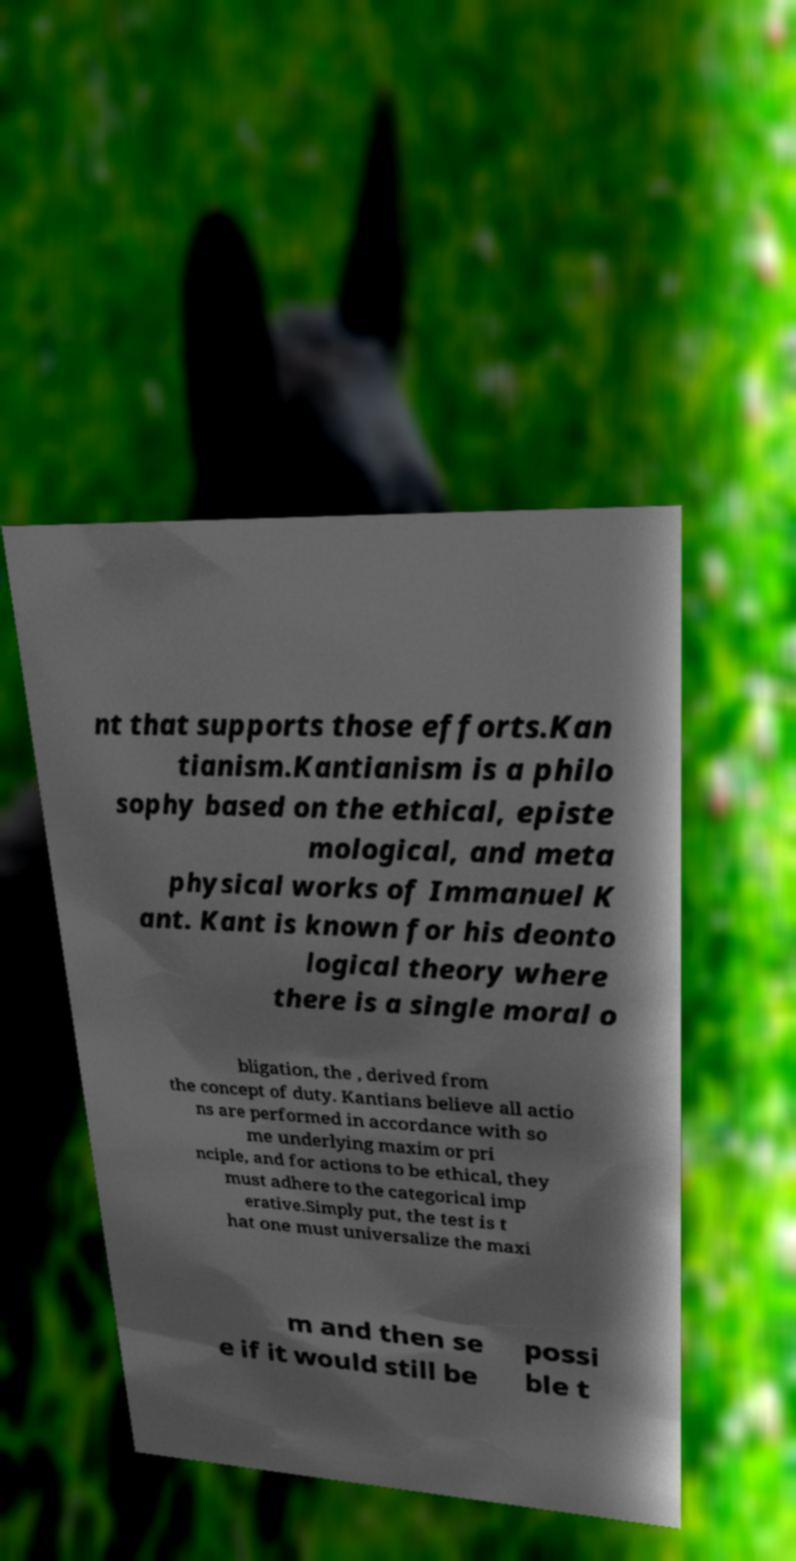There's text embedded in this image that I need extracted. Can you transcribe it verbatim? nt that supports those efforts.Kan tianism.Kantianism is a philo sophy based on the ethical, episte mological, and meta physical works of Immanuel K ant. Kant is known for his deonto logical theory where there is a single moral o bligation, the , derived from the concept of duty. Kantians believe all actio ns are performed in accordance with so me underlying maxim or pri nciple, and for actions to be ethical, they must adhere to the categorical imp erative.Simply put, the test is t hat one must universalize the maxi m and then se e if it would still be possi ble t 